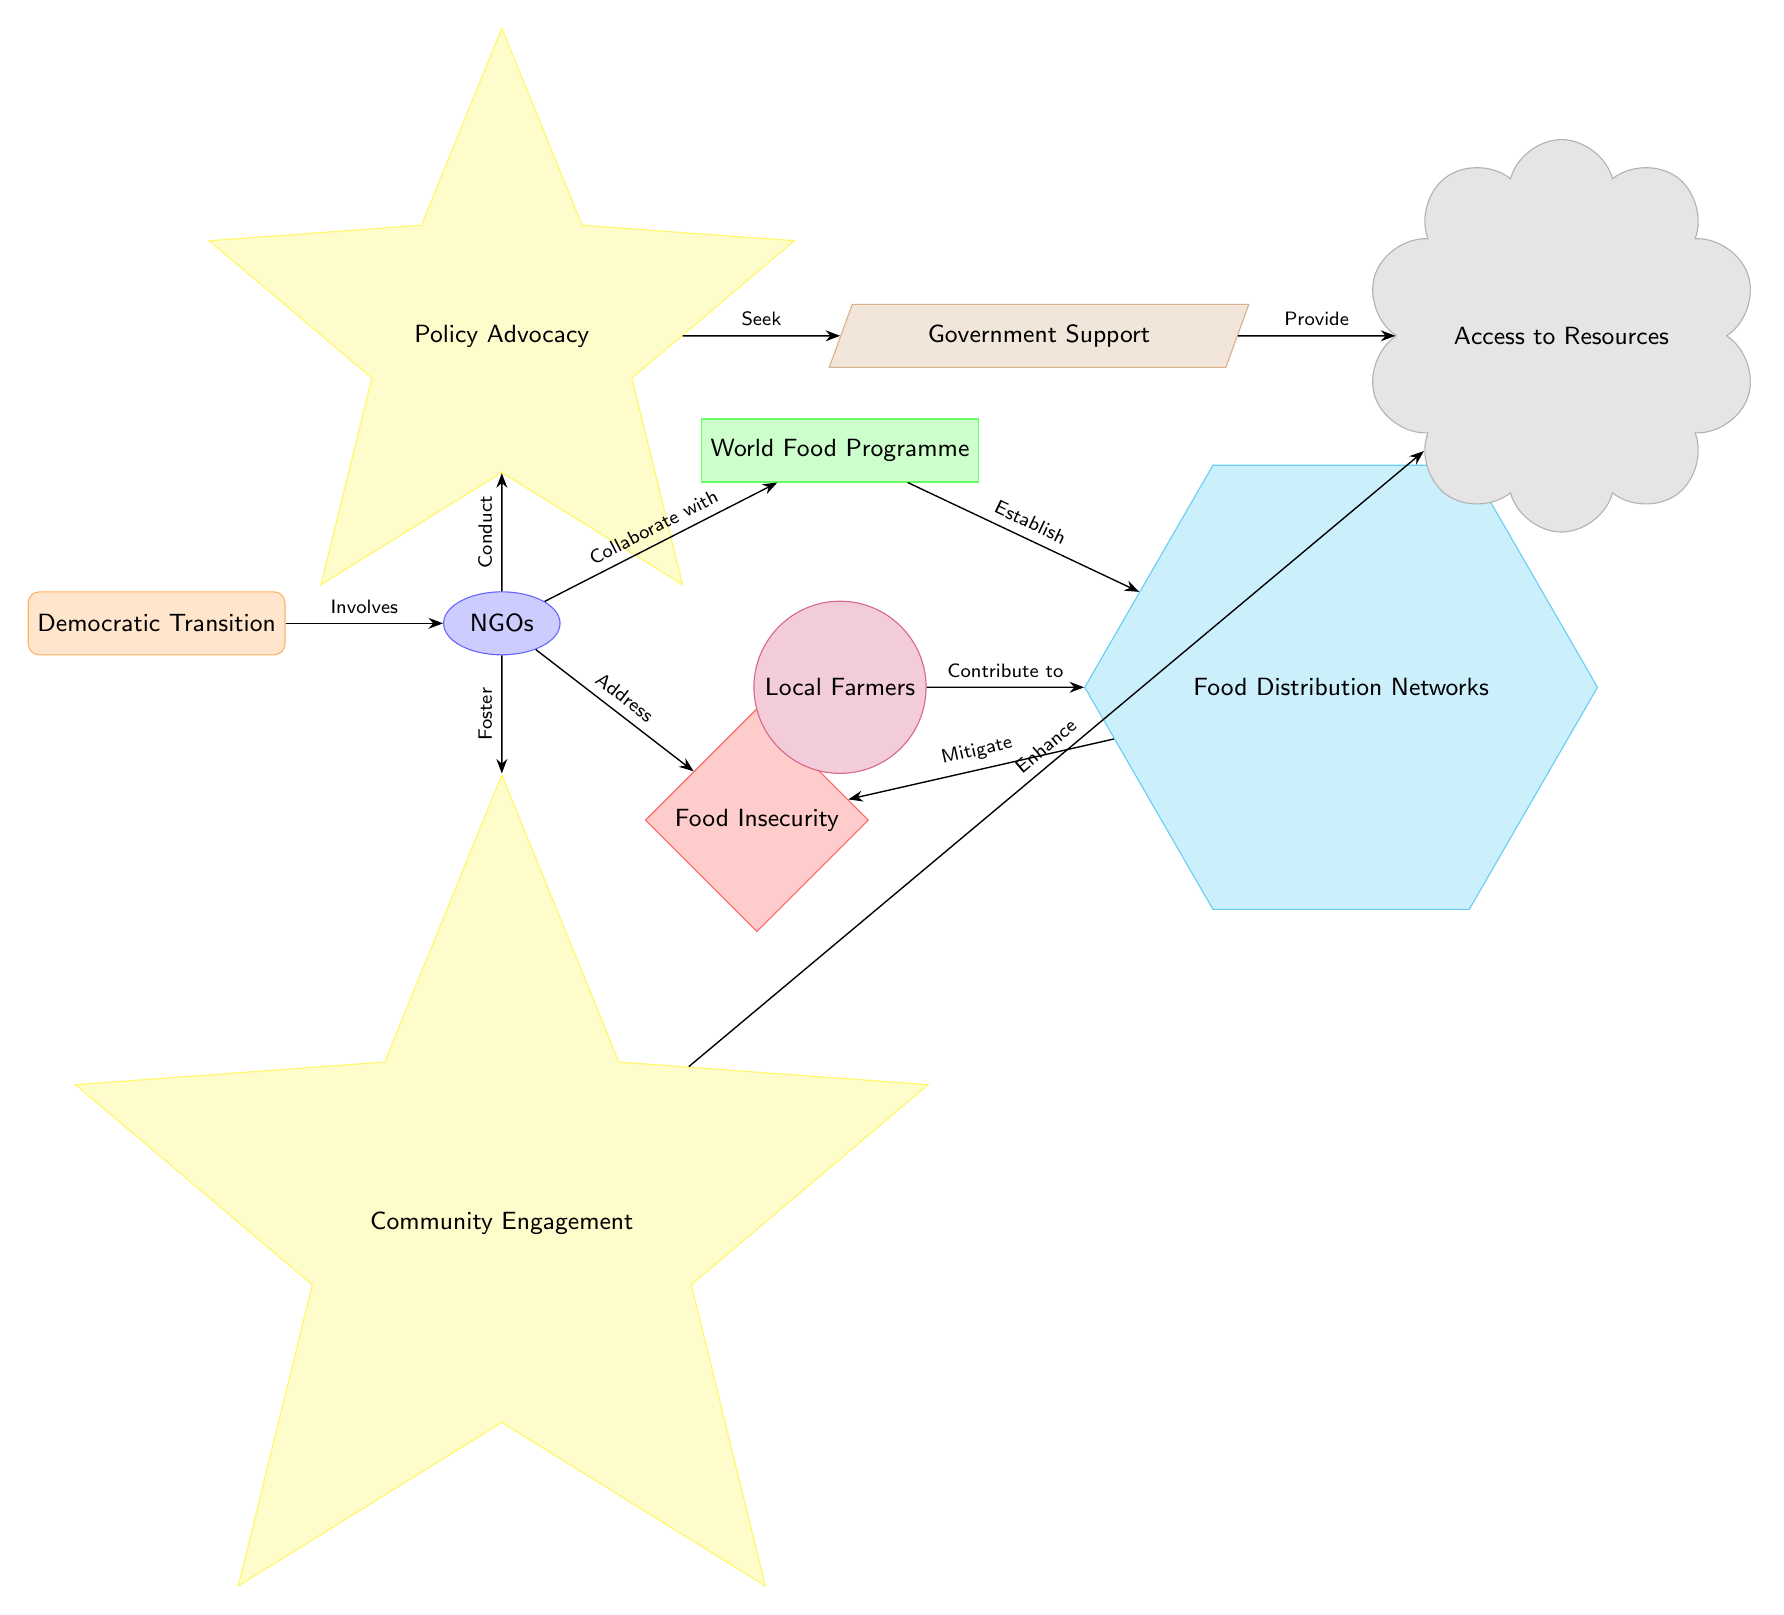What node addresses food insecurity? The node labeled "Food Insecurity" directly identifies the issue being addressed by the NGOs.
Answer: Food Insecurity How many activities are conducted by NGOs? There are two activities shown in the diagram related to NGOs: "Policy Advocacy" and "Community Engagement."
Answer: 2 What organization collaborates with NGOs? The "World Food Programme" is the organization that collaborates with the NGOs in the diagram.
Answer: World Food Programme What do NGOs seek to enhance? The NGOs seek to enhance access to resources, as indicated by the arrow from "Community Engagement" to "Access to Resources."
Answer: Access to Resources Which entity provides government support? The node labeled "Government Support" is identified as a resource sought by the NGOs for their advocacy work.
Answer: Government Support How do NGOs address food insecurity? NGOs address food insecurity by collaborating with the World Food Programme and conducting activities such as policy advocacy and community engagement.
Answer: Collaborate and conduct What contributes to food distribution networks? Local farmers contribute to food distribution networks, as shown by the relationship in the diagram.
Answer: Local Farmers What system is established by the World Food Programme? The "Food Distribution Networks" are established by the World Food Programme, as indicated by the connection from the organization to this system.
Answer: Food Distribution Networks What is the outcome of policy advocacy? The outcome of policy advocacy is described as "Access to Resources," which comes from seeking government support.
Answer: Access to Resources 